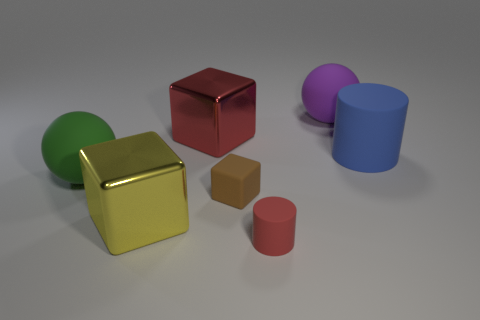Subtract all shiny cubes. How many cubes are left? 1 Add 3 metal blocks. How many objects exist? 10 Subtract all blocks. How many objects are left? 4 Subtract all cyan blocks. Subtract all cyan balls. How many blocks are left? 3 Add 5 green objects. How many green objects exist? 6 Subtract 0 gray spheres. How many objects are left? 7 Subtract all metal blocks. Subtract all big cyan shiny blocks. How many objects are left? 5 Add 3 small brown matte things. How many small brown matte things are left? 4 